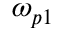Convert formula to latex. <formula><loc_0><loc_0><loc_500><loc_500>\omega _ { p 1 }</formula> 